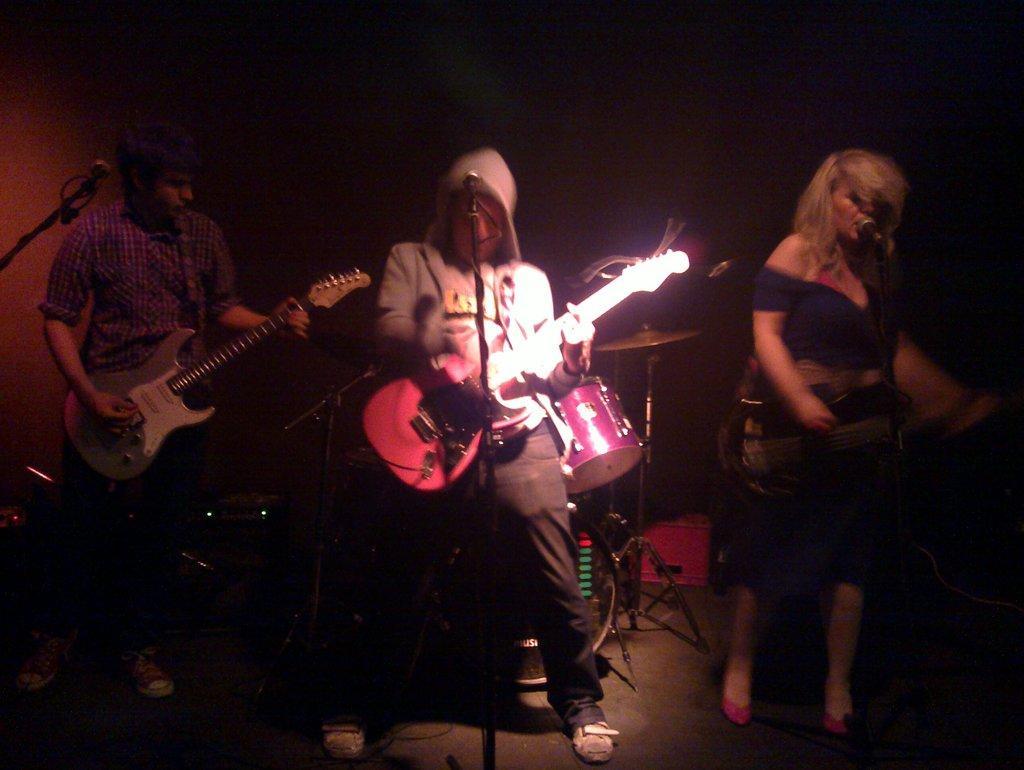Can you describe this image briefly? In this image In the middle there is a man he is playing guitar. On the right there is a woman she is singing. On the left there is a man he wears check shirt he is playing guitar. In the background there are drums. 